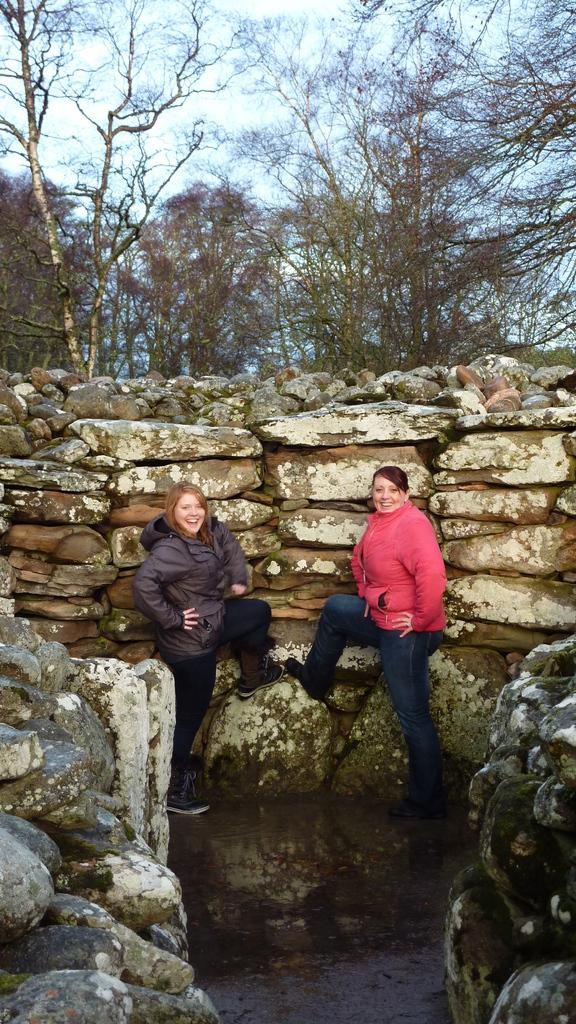What is the main object in the image? There is a rack in the image. How many people are in the image? There are two persons in the image. What can be seen at the top of the image? The sky is visible at the top of the image. What type of natural scenery is visible in the image? Trees are visible in the image. What type of fang can be seen on the throne in the image? There is no throne or fang present in the image; it features a rack and two people. 